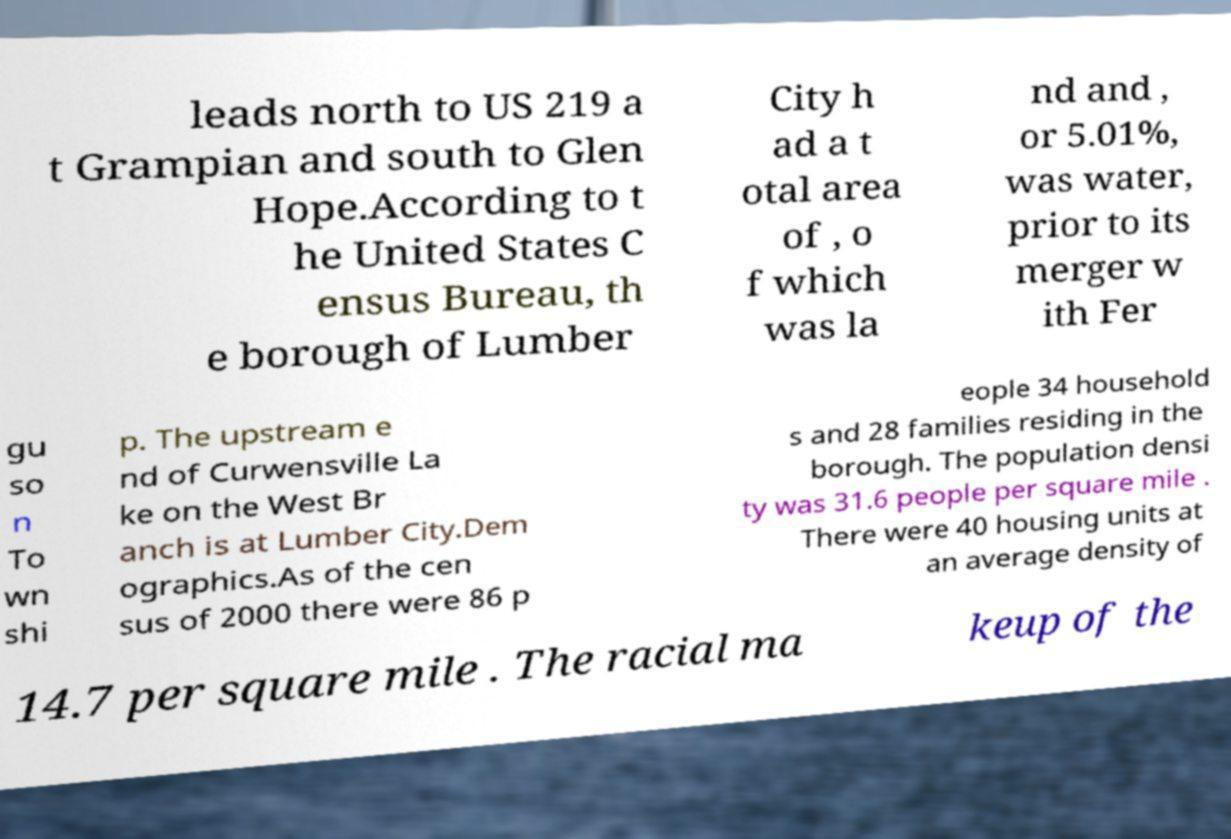Could you extract and type out the text from this image? leads north to US 219 a t Grampian and south to Glen Hope.According to t he United States C ensus Bureau, th e borough of Lumber City h ad a t otal area of , o f which was la nd and , or 5.01%, was water, prior to its merger w ith Fer gu so n To wn shi p. The upstream e nd of Curwensville La ke on the West Br anch is at Lumber City.Dem ographics.As of the cen sus of 2000 there were 86 p eople 34 household s and 28 families residing in the borough. The population densi ty was 31.6 people per square mile . There were 40 housing units at an average density of 14.7 per square mile . The racial ma keup of the 